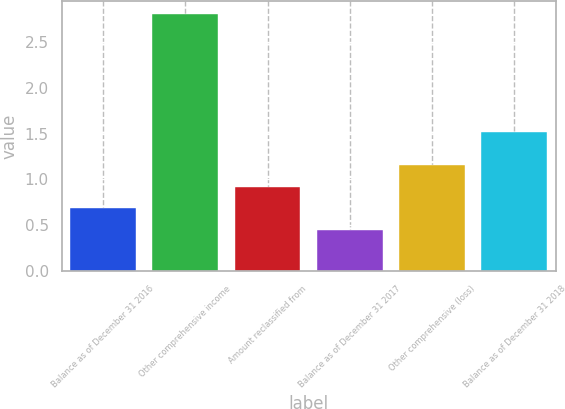Convert chart. <chart><loc_0><loc_0><loc_500><loc_500><bar_chart><fcel>Balance as of December 31 2016<fcel>Other comprehensive income<fcel>Amount reclassified from<fcel>Balance as of December 31 2017<fcel>Other comprehensive (loss)<fcel>Balance as of December 31 2018<nl><fcel>0.69<fcel>2.8<fcel>0.92<fcel>0.45<fcel>1.16<fcel>1.52<nl></chart> 